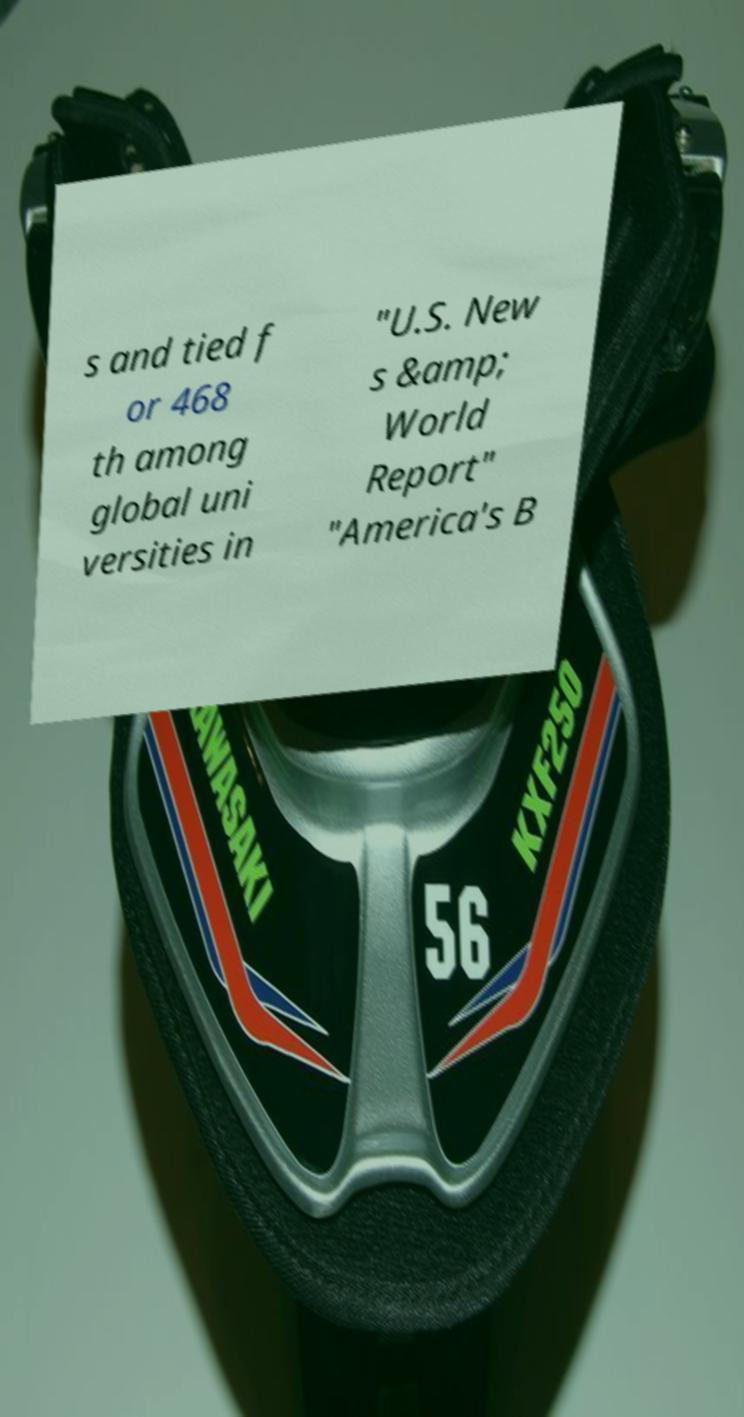I need the written content from this picture converted into text. Can you do that? s and tied f or 468 th among global uni versities in "U.S. New s &amp; World Report" "America's B 